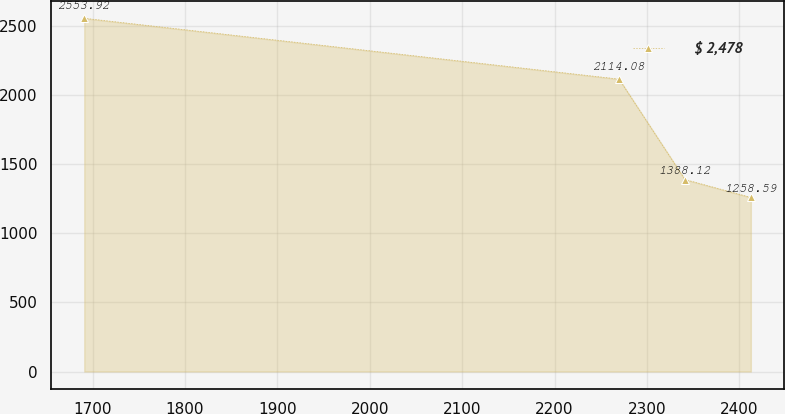<chart> <loc_0><loc_0><loc_500><loc_500><line_chart><ecel><fcel>$ 2,478<nl><fcel>1691.08<fcel>2553.92<nl><fcel>2269.89<fcel>2114.08<nl><fcel>2341.18<fcel>1388.12<nl><fcel>2412.47<fcel>1258.59<nl></chart> 